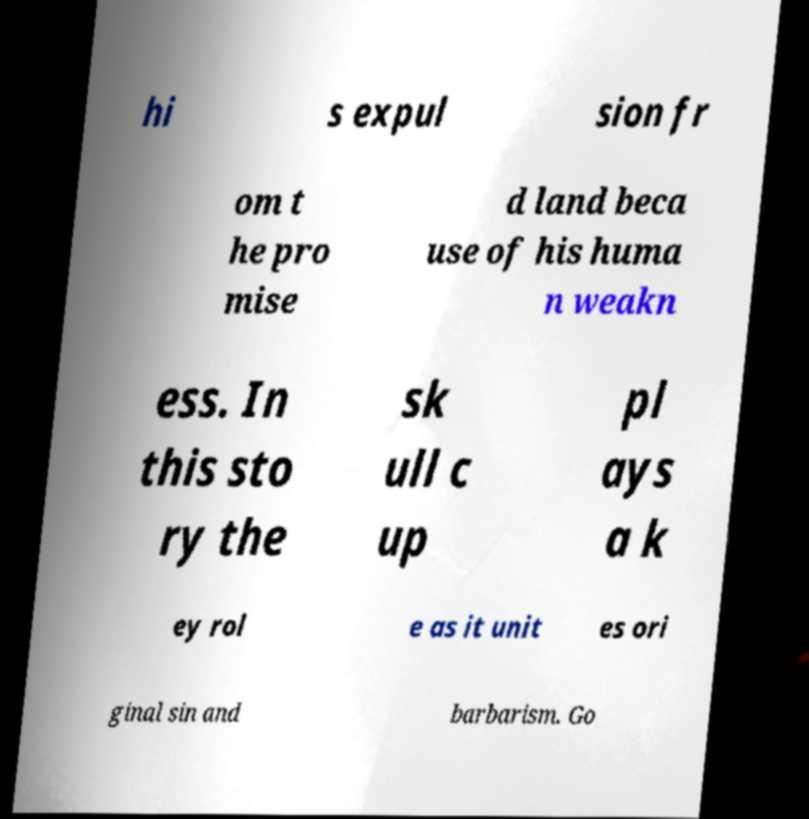For documentation purposes, I need the text within this image transcribed. Could you provide that? hi s expul sion fr om t he pro mise d land beca use of his huma n weakn ess. In this sto ry the sk ull c up pl ays a k ey rol e as it unit es ori ginal sin and barbarism. Go 